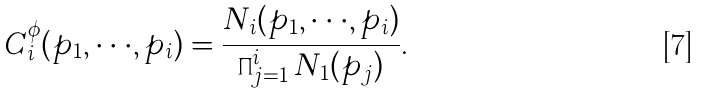<formula> <loc_0><loc_0><loc_500><loc_500>C _ { i } ^ { \phi } ( { p _ { 1 } } , \cdot \cdot \cdot , { p _ { i } } ) = \frac { N _ { i } ( { p _ { 1 } } , \cdot \cdot \cdot , { p _ { i } } ) } { \prod _ { j = 1 } ^ { i } N _ { 1 } ( { p _ { j } } ) } .</formula> 